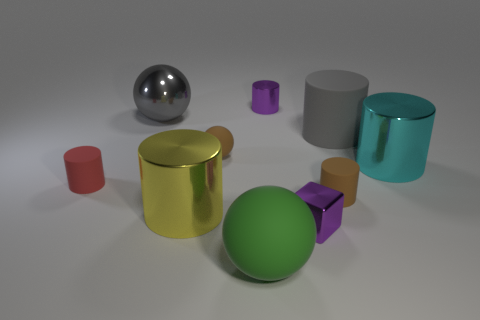What is the size of the rubber sphere in front of the purple thing in front of the brown rubber object that is behind the red thing?
Give a very brief answer. Large. Are there any small purple matte things?
Offer a very short reply. No. There is a small cylinder that is the same color as the cube; what material is it?
Offer a very short reply. Metal. What number of small shiny objects are the same color as the tiny shiny cylinder?
Your answer should be very brief. 1. How many objects are either metallic objects to the left of the brown cylinder or large matte objects that are on the right side of the gray metal ball?
Make the answer very short. 6. How many small matte cylinders are right of the brown object behind the red matte object?
Offer a very short reply. 1. What is the color of the big cylinder that is the same material as the big yellow object?
Offer a very short reply. Cyan. Are there any red rubber objects of the same size as the cyan object?
Your response must be concise. No. There is a metallic thing that is the same size as the purple metal cube; what is its shape?
Give a very brief answer. Cylinder. Is there a large thing of the same shape as the small red matte thing?
Make the answer very short. Yes. 